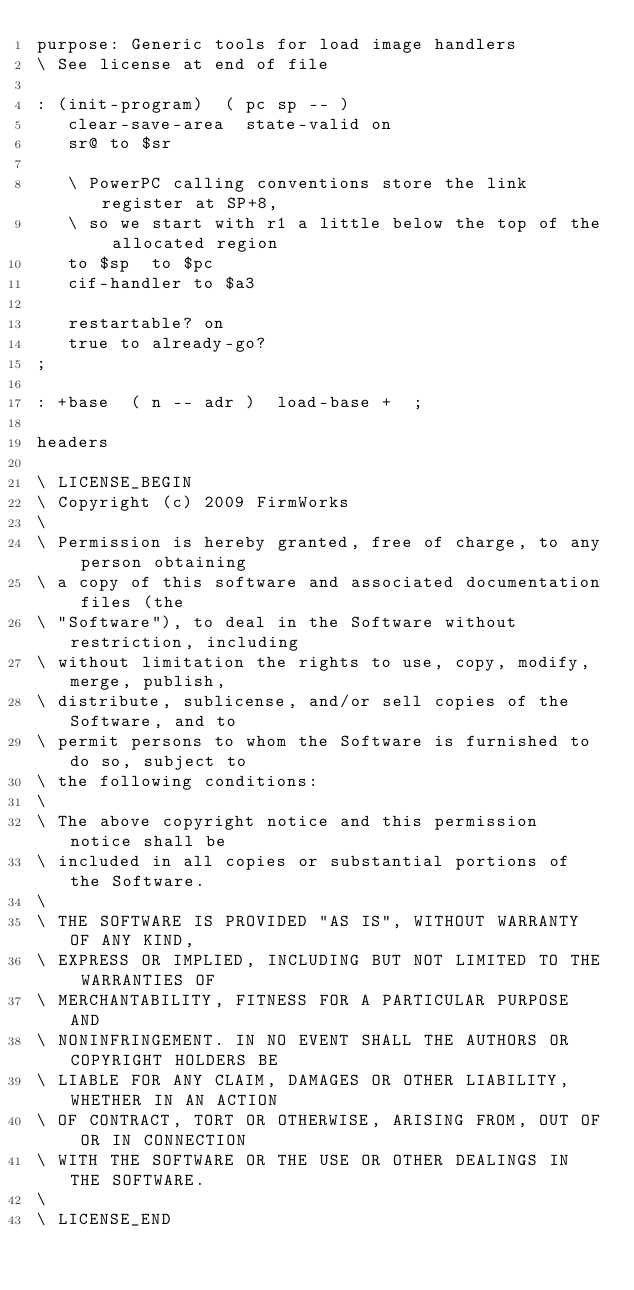Convert code to text. <code><loc_0><loc_0><loc_500><loc_500><_Forth_>purpose: Generic tools for load image handlers
\ See license at end of file

: (init-program)  ( pc sp -- )
   clear-save-area  state-valid on
   sr@ to $sr

   \ PowerPC calling conventions store the link register at SP+8,
   \ so we start with r1 a little below the top of the allocated region
   to $sp  to $pc
   cif-handler to $a3

   restartable? on
   true to already-go?
;

: +base  ( n -- adr )  load-base +  ;

headers

\ LICENSE_BEGIN
\ Copyright (c) 2009 FirmWorks
\ 
\ Permission is hereby granted, free of charge, to any person obtaining
\ a copy of this software and associated documentation files (the
\ "Software"), to deal in the Software without restriction, including
\ without limitation the rights to use, copy, modify, merge, publish,
\ distribute, sublicense, and/or sell copies of the Software, and to
\ permit persons to whom the Software is furnished to do so, subject to
\ the following conditions:
\ 
\ The above copyright notice and this permission notice shall be
\ included in all copies or substantial portions of the Software.
\ 
\ THE SOFTWARE IS PROVIDED "AS IS", WITHOUT WARRANTY OF ANY KIND,
\ EXPRESS OR IMPLIED, INCLUDING BUT NOT LIMITED TO THE WARRANTIES OF
\ MERCHANTABILITY, FITNESS FOR A PARTICULAR PURPOSE AND
\ NONINFRINGEMENT. IN NO EVENT SHALL THE AUTHORS OR COPYRIGHT HOLDERS BE
\ LIABLE FOR ANY CLAIM, DAMAGES OR OTHER LIABILITY, WHETHER IN AN ACTION
\ OF CONTRACT, TORT OR OTHERWISE, ARISING FROM, OUT OF OR IN CONNECTION
\ WITH THE SOFTWARE OR THE USE OR OTHER DEALINGS IN THE SOFTWARE.
\
\ LICENSE_END
</code> 